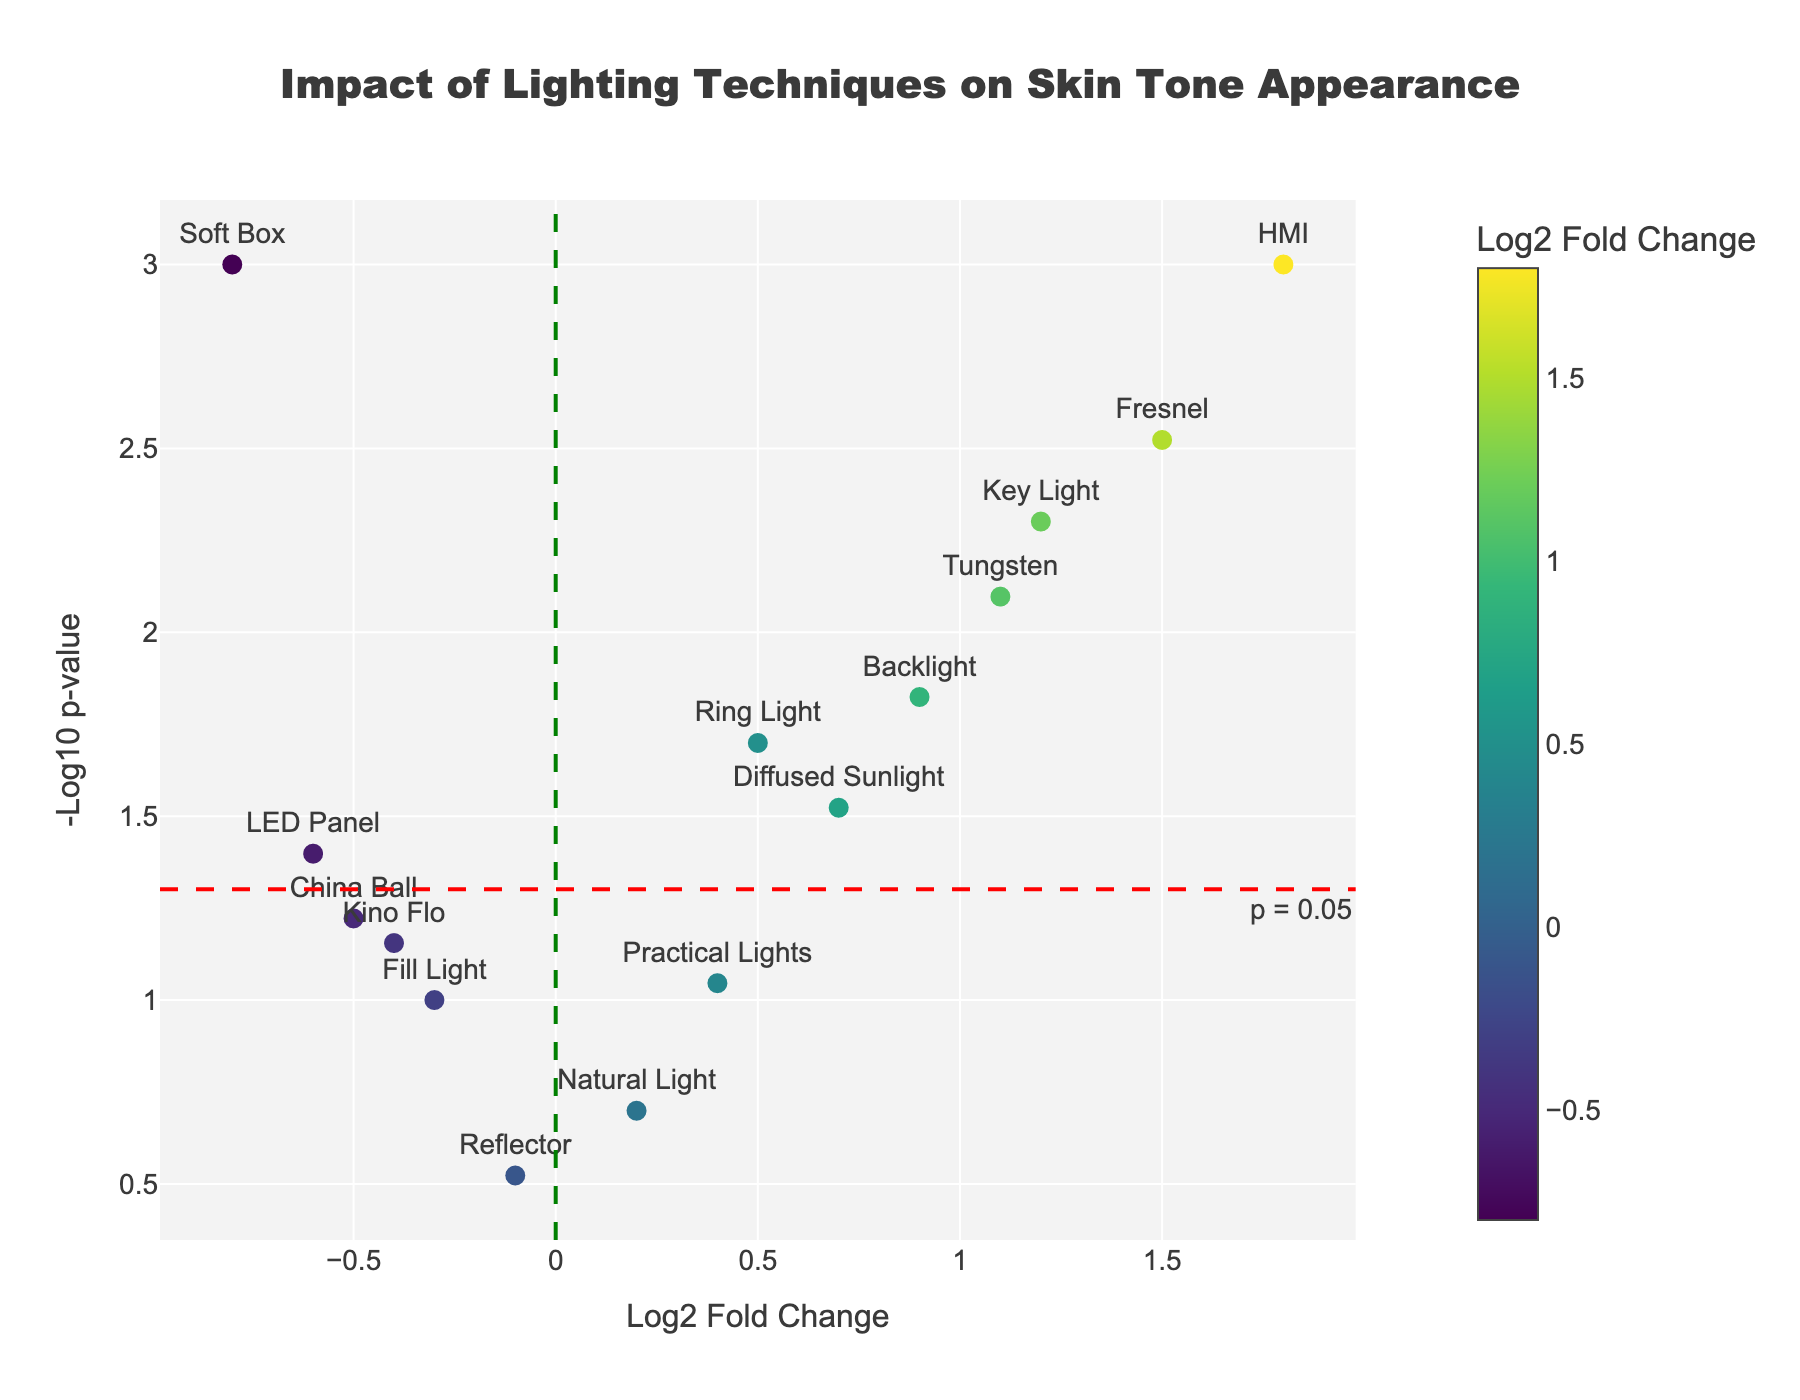what's the title of the figure? The title is prominently displayed at the top of the figure in a larger and bold font. It reads, "Impact of Lighting Techniques on Skin Tone Appearance."
Answer: Impact of Lighting Techniques on Skin Tone Appearance How many lighting techniques have a p-value significant below 0.05? To determine the number of techniques with significant p-values, locate the horizontal red dashed line representing p = 0.05, then count the data points above this line. There are 9 such points.
Answer: 9 Which lighting technique has the highest log2 fold change? Find the data point farthest right on the x-axis to identify the technique with the highest log2 fold change. It corresponds to HMI with a log2 fold change of 1.8.
Answer: HMI Which lighting technique has the lowest log2 fold change? Find the data point farthest left on the x-axis to identify the technique with the lowest log2 fold change. It corresponds to Soft Box with a log2 fold change of -0.8.
Answer: Soft Box How does the p-value of Key Light compare to that of Tungsten? Locate the data points for Key Light and Tungsten on the plot. Key Light is at y = -log10(0.005) ≈ 2.3, and Tungsten is at y = -log10(0.008) ≈ 2.1. Key Light has a slightly lower p-value than Tungsten.
Answer: Key Light's p-value is lower What lighting technique is closest to the intersecting lines (log2_fold_change = 0 and -log10_p = 1.3)? Locate the intersection point and observe the nearest data point, which is Natural Light.
Answer: Natural Light Which lighting techniques have both a log2 fold change above 0 and a p-value below 0.05? Identify techniques with data points to the right of the green line (log2 fold change > 0) and above the red horizontal line (p-value < 0.05). These are Ring Light, Key Light, Backlight, Fresnel, Tungsten, and HMI.
Answer: Ring Light, Key Light, Backlight, Fresnel, Tungsten, HMI 